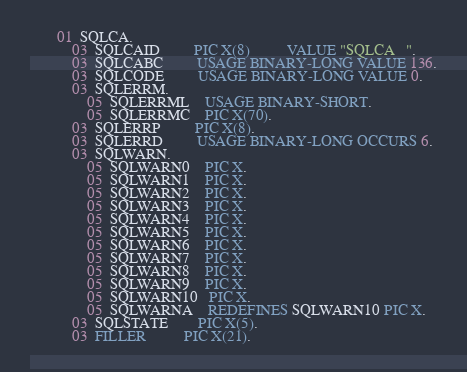<code> <loc_0><loc_0><loc_500><loc_500><_COBOL_>       01  SQLCA.
           03  SQLCAID         PIC X(8)          VALUE "SQLCA   ".
           03  SQLCABC         USAGE BINARY-LONG VALUE 136.
           03  SQLCODE         USAGE BINARY-LONG VALUE 0.
           03  SQLERRM.
               05  SQLERRML    USAGE BINARY-SHORT.
               05  SQLERRMC    PIC X(70).
           03  SQLERRP         PIC X(8).
           03  SQLERRD         USAGE BINARY-LONG OCCURS 6.
           03  SQLWARN.
               05  SQLWARN0    PIC X.
               05  SQLWARN1    PIC X.
               05  SQLWARN2    PIC X.
               05  SQLWARN3    PIC X.
               05  SQLWARN4    PIC X.
               05  SQLWARN5    PIC X.
               05  SQLWARN6    PIC X.
               05  SQLWARN7    PIC X.
               05  SQLWARN8    PIC X.
               05  SQLWARN9    PIC X.
               05  SQLWARN10   PIC X.
               05  SQLWARNA    REDEFINES SQLWARN10 PIC X.
           03  SQLSTATE        PIC X(5).
           03  FILLER          PIC X(21).
</code> 